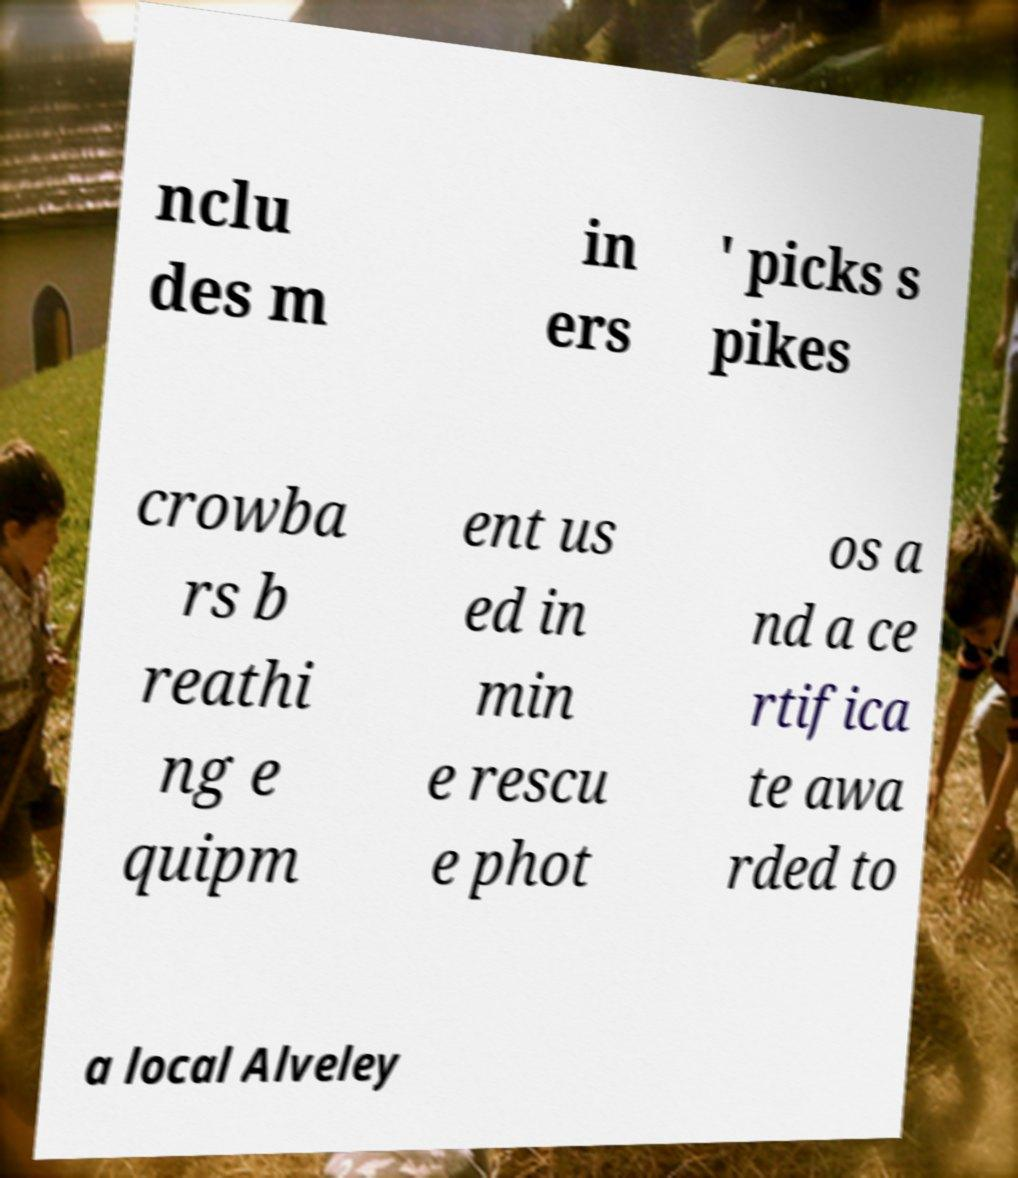For documentation purposes, I need the text within this image transcribed. Could you provide that? nclu des m in ers ' picks s pikes crowba rs b reathi ng e quipm ent us ed in min e rescu e phot os a nd a ce rtifica te awa rded to a local Alveley 